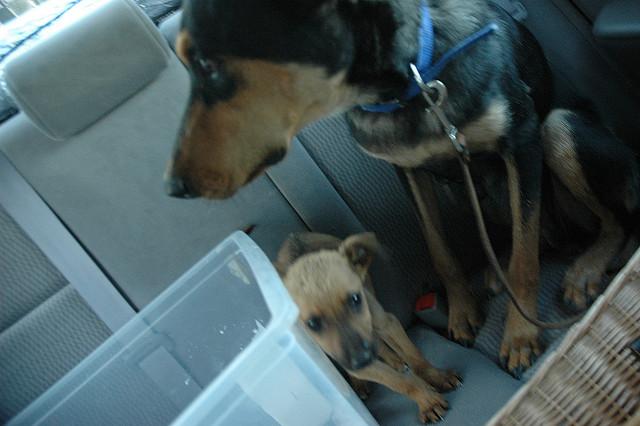Is the larger dog attacking the smaller one?
Answer briefly. No. Are both dogs on a leash?
Keep it brief. No. What color is the dog?
Quick response, please. Brown and black. What color are the seats?
Write a very short answer. Gray. What is in the backseat?
Give a very brief answer. Dogs. Are these animals outdoors?
Be succinct. No. 